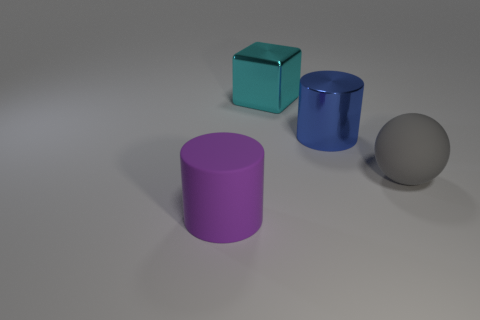What is the big cylinder on the right side of the big matte object that is in front of the rubber object behind the purple rubber cylinder made of?
Your answer should be compact. Metal. There is a matte object that is in front of the big gray sphere; is its shape the same as the matte object that is right of the big metal block?
Provide a succinct answer. No. How many other things are the same material as the large gray sphere?
Provide a succinct answer. 1. Is the material of the thing that is left of the big block the same as the thing that is behind the metallic cylinder?
Give a very brief answer. No. There is a blue thing that is the same material as the large block; what shape is it?
Your response must be concise. Cylinder. Are there any other things that have the same color as the shiny cylinder?
Keep it short and to the point. No. How many large purple objects are there?
Keep it short and to the point. 1. What shape is the large object that is in front of the blue cylinder and right of the cyan metallic thing?
Make the answer very short. Sphere. There is a metallic thing that is on the left side of the large metal thing that is on the right side of the big object behind the blue cylinder; what shape is it?
Ensure brevity in your answer.  Cube. What is the material of the object that is on the left side of the big ball and in front of the large blue shiny object?
Your answer should be compact. Rubber. 